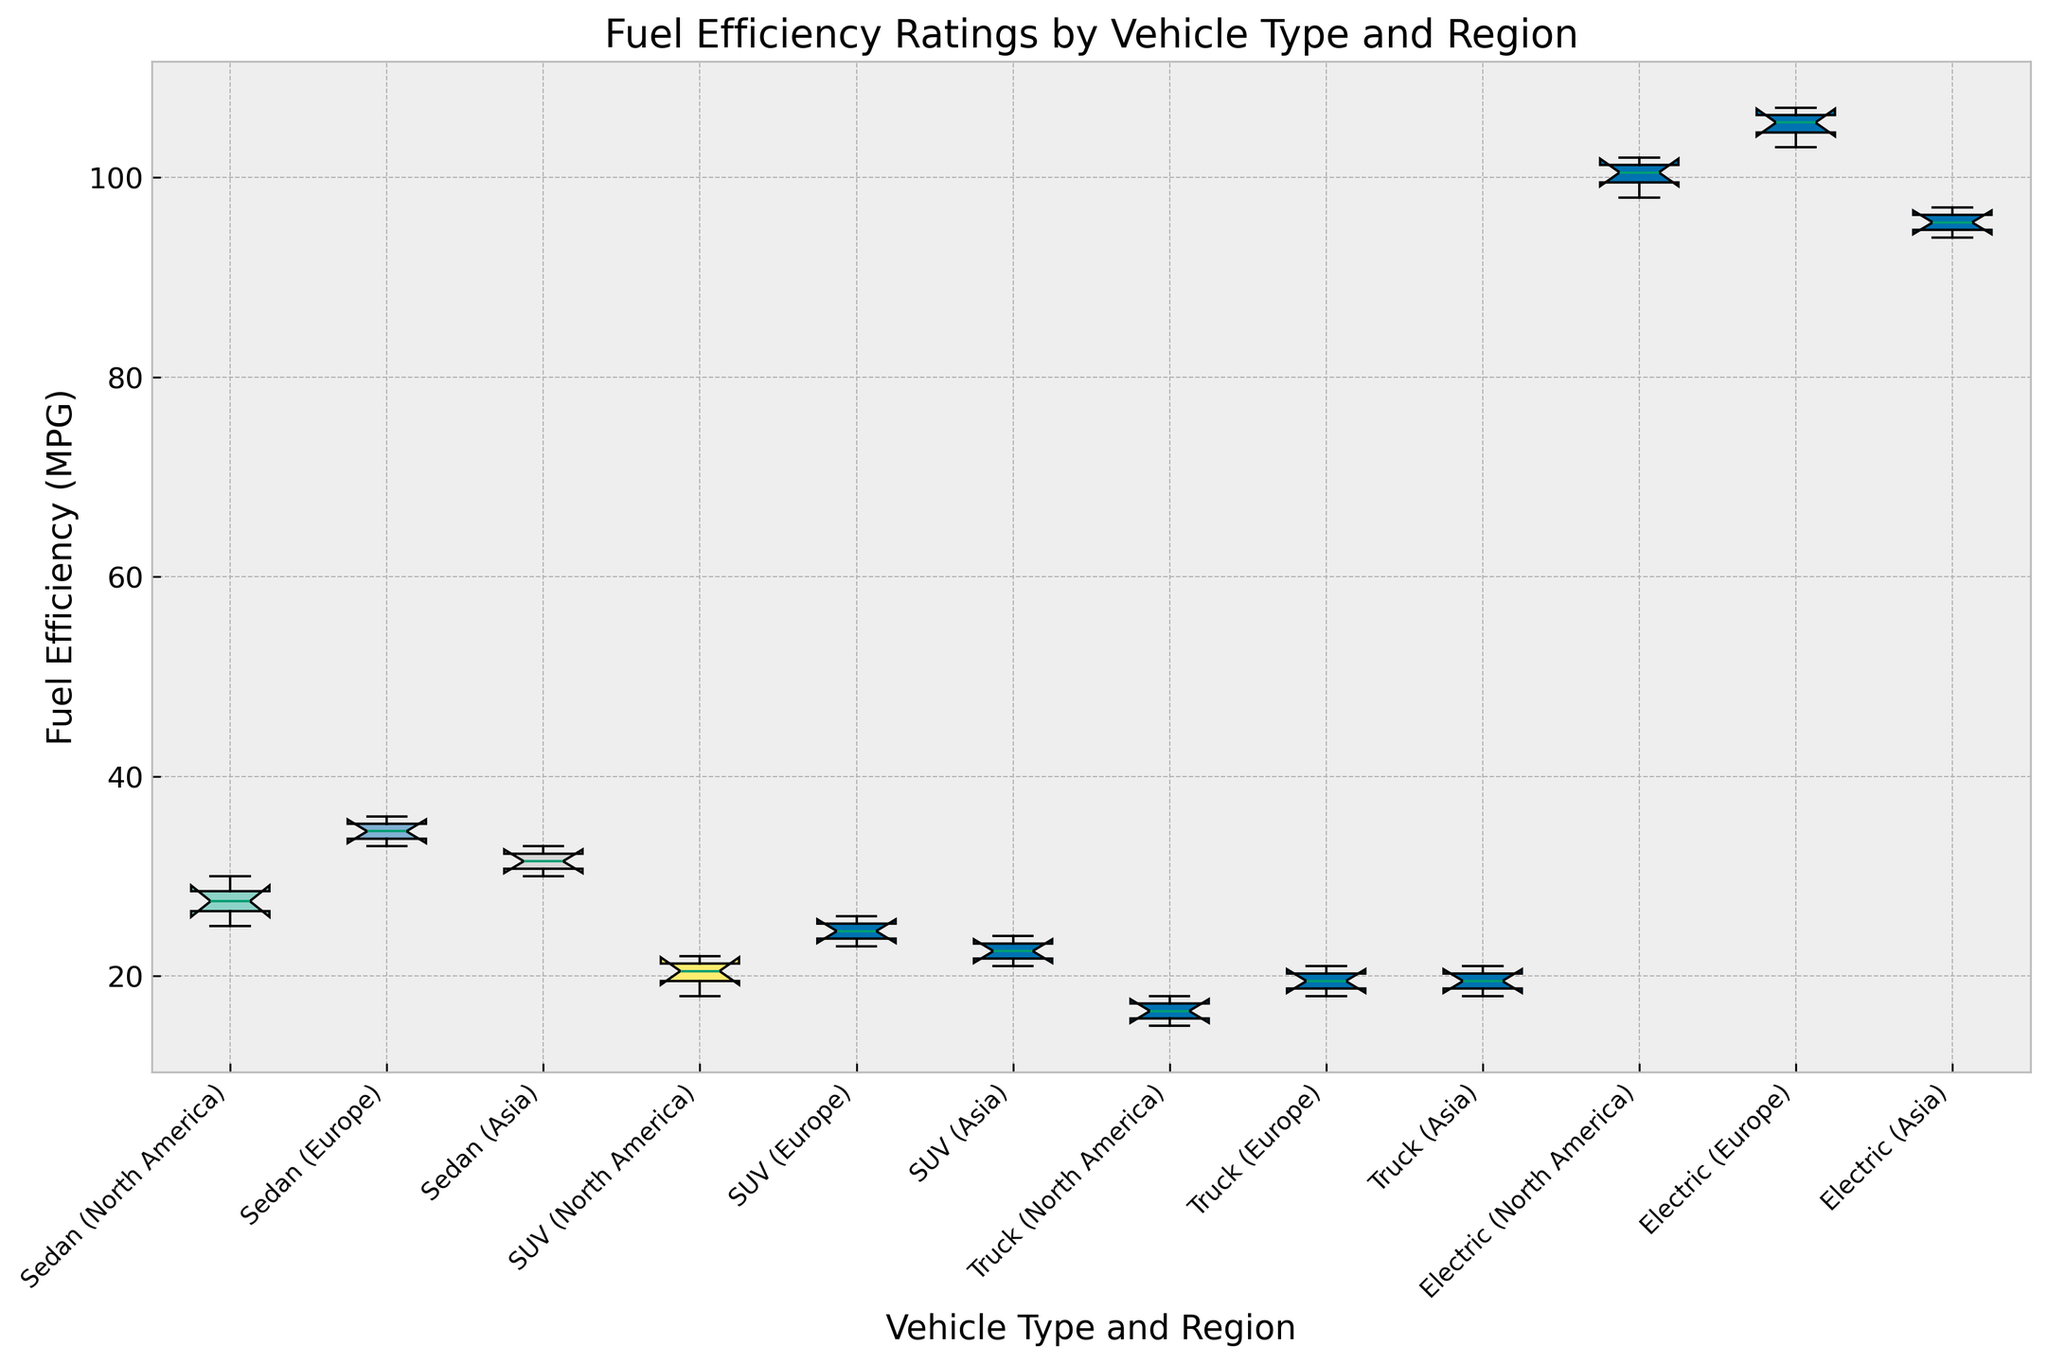What's the median fuel efficiency of sedans in Europe? The fuel efficiency values for sedans in Europe are 33, 34, 35, and 36. To find the median, we need to identify the middle values (34 and 35) and calculate their average: (34 + 35) / 2 = 34.5
Answer: 34.5 Which vehicle type has the highest median fuel efficiency in North America? We need to compare the median fuel efficiencies of each vehicle type in North America. For sedans (25, 27, 28, 30), the median is 27. For SUVs (18, 20, 21, 22), the median is 20.5. For trucks (15, 16, 17, 18), the median is 16.5. For electric vehicles (98, 100, 101, 102), the median is 100.5. The highest median is 100.5 for electric vehicles.
Answer: Electric What is the interquartile range (IQR) of trucks in Asia? The fuel efficiency values for trucks in Asia are 18, 19, 20, and 21. The first quartile (Q1) is 18.5 and the third quartile (Q3) is 20.5. IQR = Q3 - Q1 = 20.5 - 18.5 = 2
Answer: 2 Which region has the most consistent fuel efficiency for SUVs in terms of range? Consistency can be judged by the range (difference between maximum and minimum). For SUVs, North America has values 18, 20, 21, 22 (range = 22 - 18 = 4), Europe has values 23, 24, 25, 26 (range = 26 - 23 = 3), and Asia has values 21, 22, 23, 24 (range = 24 - 21 = 3). Europe and Asia have the same smallest range, so they are equally consistent.
Answer: Europe and Asia Compare the maximum fuel efficiency of electric vehicles across all regions. The maximum fuel efficiency values of electric vehicles in each region are: North America (102), Europe (107), and Asia (97). Europe has the highest maximum value (107), and Asia has the lowest (97).
Answer: Europe's is highest (107), Asia's is lowest (97) Which vehicle type has the widest spread in fuel efficiency in any region? The spread can be measured by the difference between the maximum and minimum values. The values are: Sedans in North America (30-25=5), Europe (36-33=3), Asia (33-30=3), SUVs in North America (22-18=4), Europe (26-23=3), Asia (24-21=3), Trucks in North America (18-15=3), Europe (21-18=3), Asia (21-18=3), Electric vehicles in North America (102-98=4), Europe (107-103=4), Asia (97-94=3). Sedans in North America have the highest spread of (5).
Answer: Sedans in North America What's the difference between the median fuel efficiencies of sedans in Europe and Asia? The fuel efficiency median for sedans in Europe is 34.5 and for Asia, the median is 31.5 (from 30, 31, 32, and 33). The difference between these medians is 34.5 - 31.5 = 3
Answer: 3 Is the median fuel efficiency of SUVs in Europe greater than that of trucks in North America? The median for SUVs in Europe is calculated from 23, 24, 25, and 26, which is (24 + 25) / 2 = 24.5, and for trucks in North America, from 15, 16, 17, and 18, which is (16 + 17) / 2 = 16.5. Since 24.5 > 16.5, the median is greater for SUVs in Europe.
Answer: Yes Which vehicle type exhibits the least variation in fuel efficiency across all regions? Variation can be assessed by looking at the boxes' height in the box plot representing the IQR (Interquartile Range). For each vehicle type across all regions: Sedans, SUVs, Trucks, and Electric Vehicles - comparing the height of their boxes shows that electric vehicles exhibit the least variation as their IQR is most condensed.
Answer: Electric What's the difference between the highest and lowest fuel efficiency values observed for sedans across all regions? The highest fuel efficiency observed for sedans is 36 (Sedan in Europe) and the lowest is 25 (Sedan in North America). The difference between these values is 36 - 25 = 11.
Answer: 11 